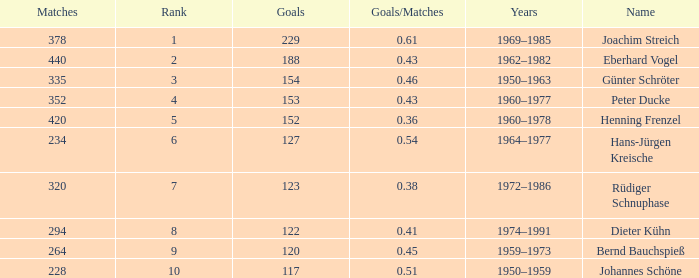What average goals have matches less than 228? None. 